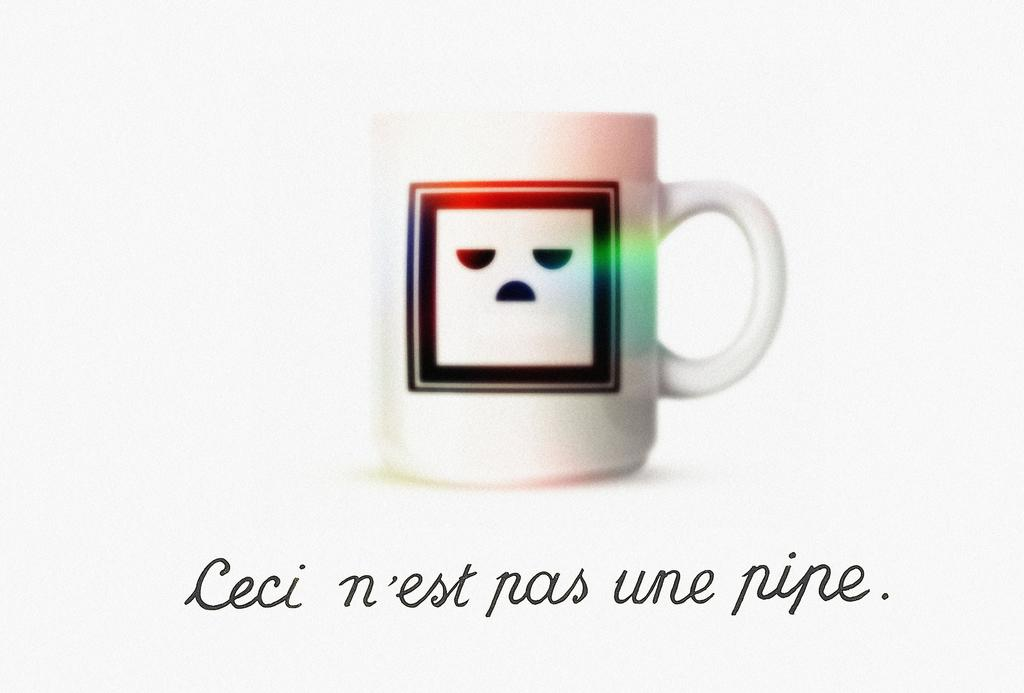Provide a one-sentence caption for the provided image. a mug with an unhappy face decal on it reading ceci n'est pas une pipe. 